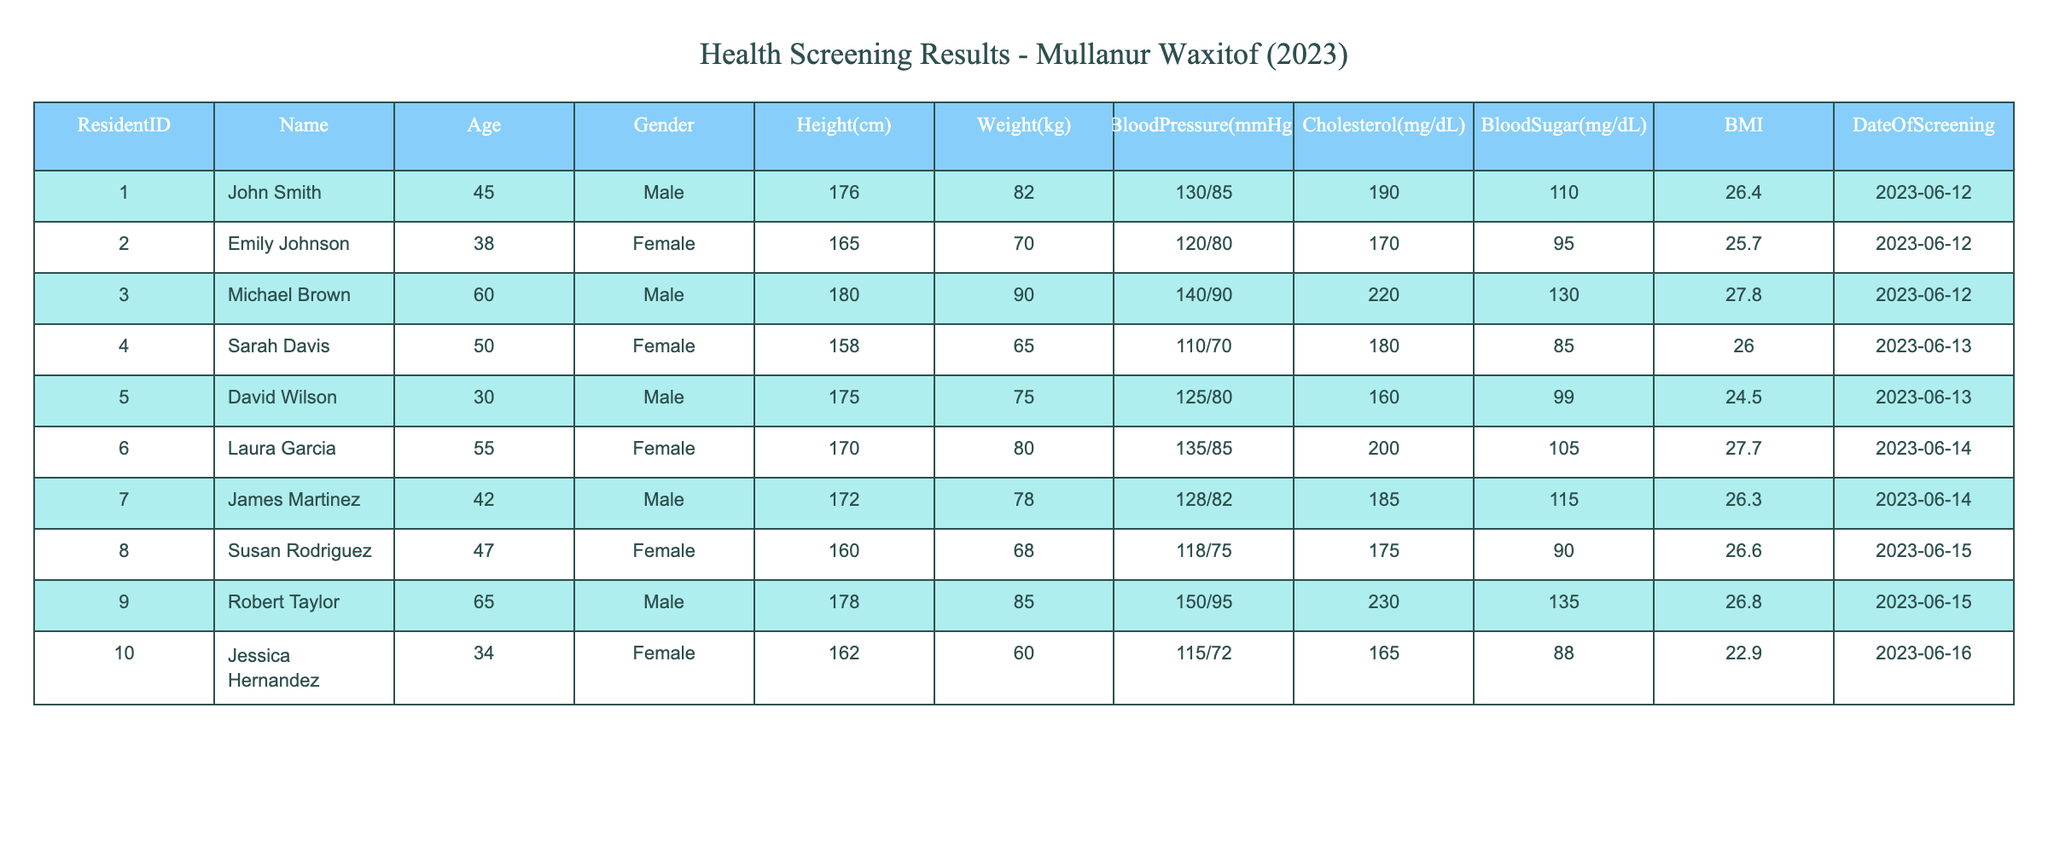What is the BMI of Sarah Davis? To find Sarah Davis's BMI, I refer to the row with her name in the table. In that row, the BMI is listed as 26.0.
Answer: 26.0 Which resident has the highest cholesterol level? I check each resident's cholesterol level in the Cholesterol column. Michael Brown has the highest value of 220 mg/dL.
Answer: Michael Brown What is the average age of the residents listed in the table? I sum the ages of all residents: 45 + 38 + 60 + 50 + 30 + 55 + 42 + 47 + 65 + 34 =  416. There are 10 residents, so the average age is 416 / 10 = 41.6.
Answer: 41.6 Is Laura Garcia's blood pressure higher than 130/85? I look at Laura Garcia's blood pressure in the table, which is listed as 135/85. This is indeed higher than 130/85.
Answer: Yes What is the difference between the highest and lowest blood sugar levels in the table? The highest blood sugar level is 135 (Robert Taylor) and the lowest is 85 (Sarah Davis). The difference is 135 - 85 = 50.
Answer: 50 What percentage of residents have a BMI above 26? First, I identify who has a BMI above 26: John Smith, Michael Brown, Laura Garcia, James Martinez, and Robert Taylor. There are 5 out of 10 residents, so the percentage is (5/10) * 100 = 50%.
Answer: 50% How many male residents have a blood pressure reading of 130/85 or higher? I find the male residents with blood pressure readings: John Smith (130/85), Michael Brown (140/90), David Wilson (125/80), James Martinez (128/82), and Robert Taylor (150/95). This includes John Smith, Michael Brown, and Robert Taylor, making a total of 3.
Answer: 3 What is the cholesterol level of the youngest resident? Checking the ages, David Wilson is the youngest at 30 years old. His cholesterol level is 160 mg/dL.
Answer: 160 mg/dL Which resident has the lowest weight, and what is that weight? I examine the weight column to find the lowest value. Jessica Hernandez has the lowest weight at 60 kg.
Answer: 60 kg 